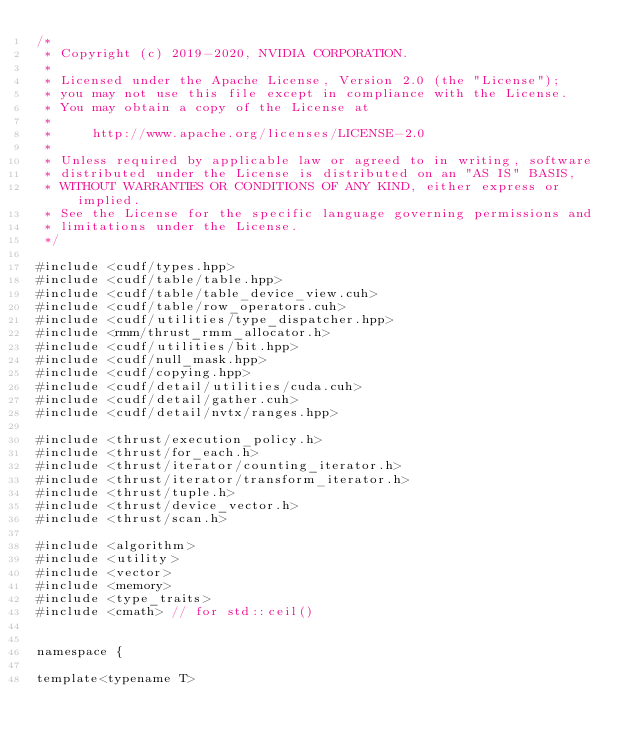<code> <loc_0><loc_0><loc_500><loc_500><_Cuda_>/*
 * Copyright (c) 2019-2020, NVIDIA CORPORATION.
 *
 * Licensed under the Apache License, Version 2.0 (the "License");
 * you may not use this file except in compliance with the License.
 * You may obtain a copy of the License at
 *
 *     http://www.apache.org/licenses/LICENSE-2.0
 *
 * Unless required by applicable law or agreed to in writing, software
 * distributed under the License is distributed on an "AS IS" BASIS,
 * WITHOUT WARRANTIES OR CONDITIONS OF ANY KIND, either express or implied.
 * See the License for the specific language governing permissions and
 * limitations under the License.
 */

#include <cudf/types.hpp>
#include <cudf/table/table.hpp>
#include <cudf/table/table_device_view.cuh>
#include <cudf/table/row_operators.cuh>
#include <cudf/utilities/type_dispatcher.hpp>
#include <rmm/thrust_rmm_allocator.h>
#include <cudf/utilities/bit.hpp>
#include <cudf/null_mask.hpp>
#include <cudf/copying.hpp>
#include <cudf/detail/utilities/cuda.cuh>
#include <cudf/detail/gather.cuh>
#include <cudf/detail/nvtx/ranges.hpp>

#include <thrust/execution_policy.h>
#include <thrust/for_each.h>
#include <thrust/iterator/counting_iterator.h>
#include <thrust/iterator/transform_iterator.h>
#include <thrust/tuple.h>
#include <thrust/device_vector.h>
#include <thrust/scan.h>

#include <algorithm>
#include <utility>
#include <vector>
#include <memory>
#include <type_traits>
#include <cmath> // for std::ceil()


namespace {
  
template<typename T></code> 